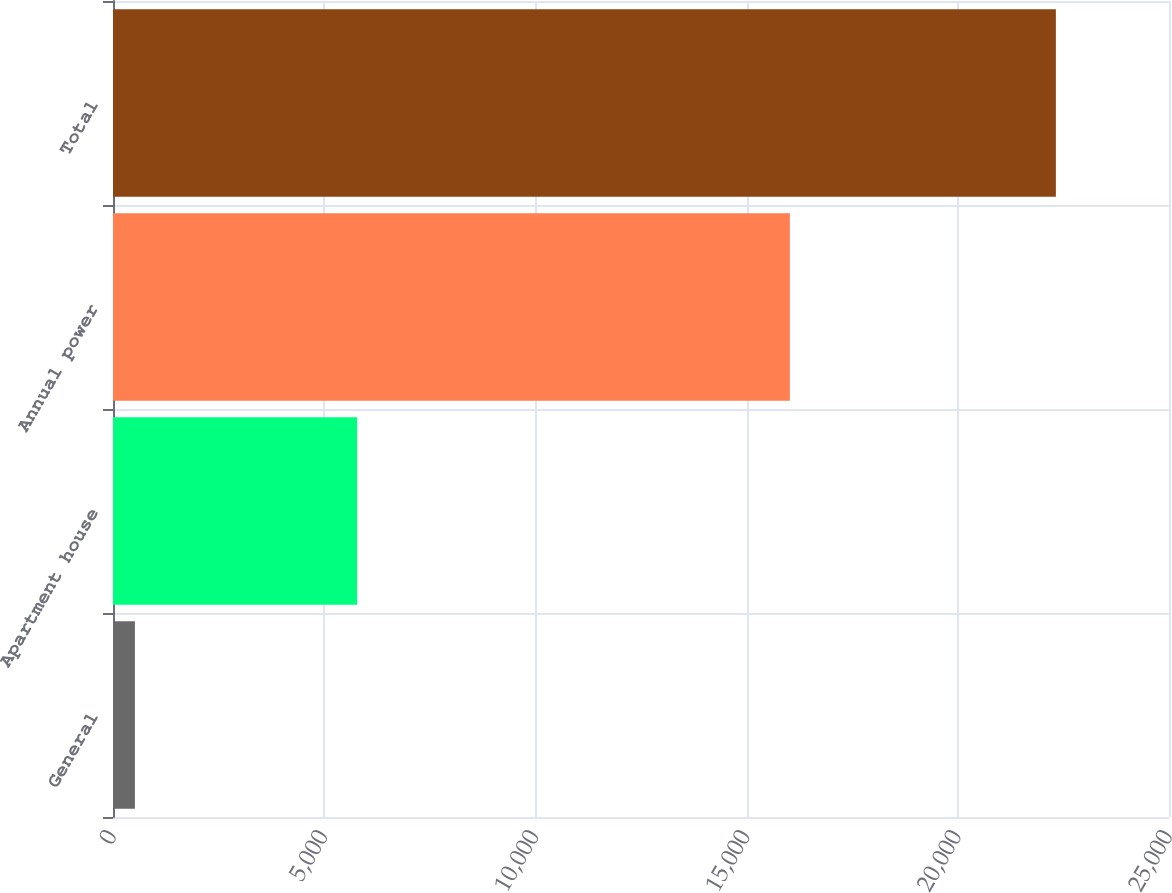Convert chart to OTSL. <chart><loc_0><loc_0><loc_500><loc_500><bar_chart><fcel>General<fcel>Apartment house<fcel>Annual power<fcel>Total<nl><fcel>519<fcel>5779<fcel>16024<fcel>22322<nl></chart> 